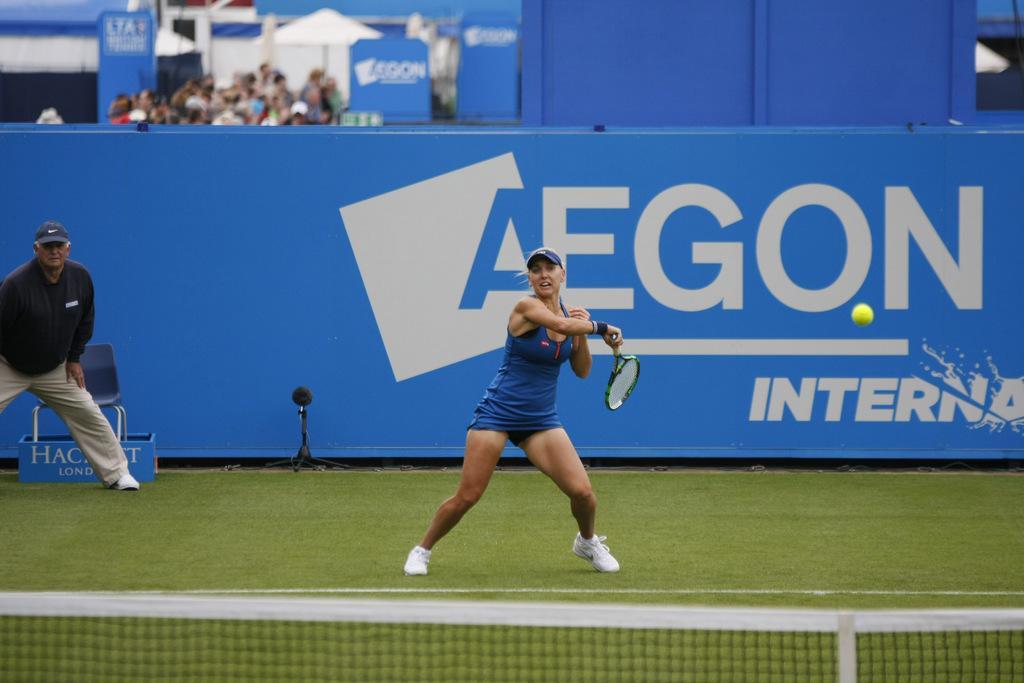How would you summarize this image in a sentence or two? In this image we can see a woman holding a racket and playing in the court. We can see net, banner and few people in the background. 